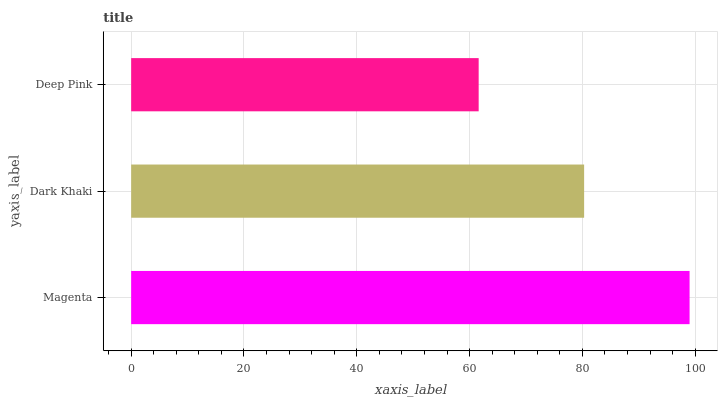Is Deep Pink the minimum?
Answer yes or no. Yes. Is Magenta the maximum?
Answer yes or no. Yes. Is Dark Khaki the minimum?
Answer yes or no. No. Is Dark Khaki the maximum?
Answer yes or no. No. Is Magenta greater than Dark Khaki?
Answer yes or no. Yes. Is Dark Khaki less than Magenta?
Answer yes or no. Yes. Is Dark Khaki greater than Magenta?
Answer yes or no. No. Is Magenta less than Dark Khaki?
Answer yes or no. No. Is Dark Khaki the high median?
Answer yes or no. Yes. Is Dark Khaki the low median?
Answer yes or no. Yes. Is Magenta the high median?
Answer yes or no. No. Is Magenta the low median?
Answer yes or no. No. 